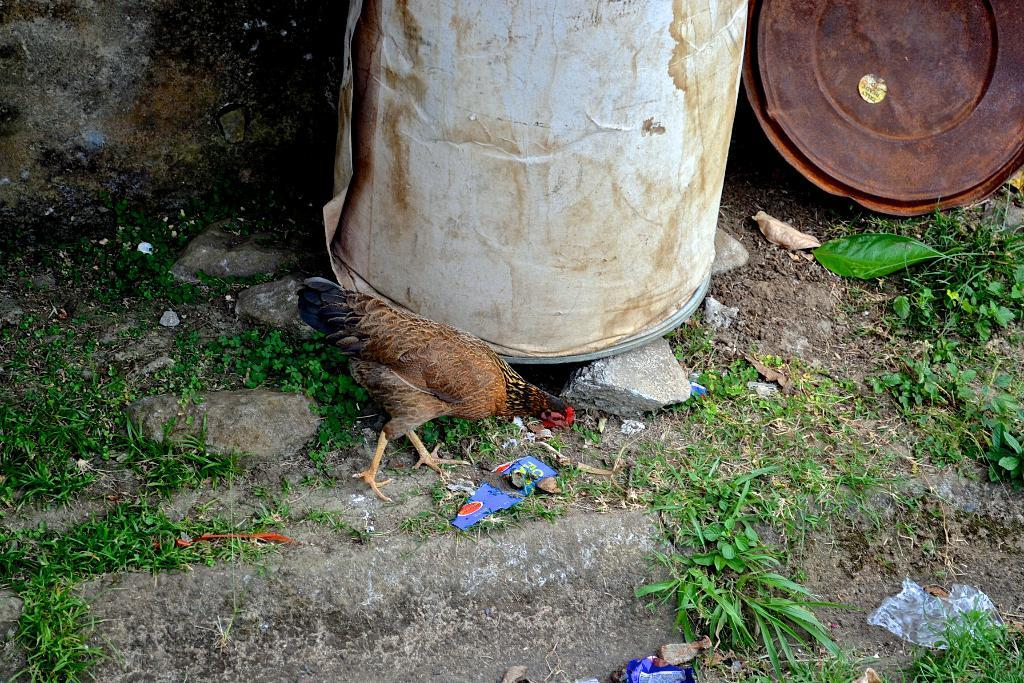What type of animal is in the image? There is a hen in the image. What objects are near the hen? There are barrels near the hen. What items are on the ground in the image? There are covers, plants, and stones on the ground. What type of pickle is the hen holding in the image? There is no pickle present in the image; the hen is not holding anything. 